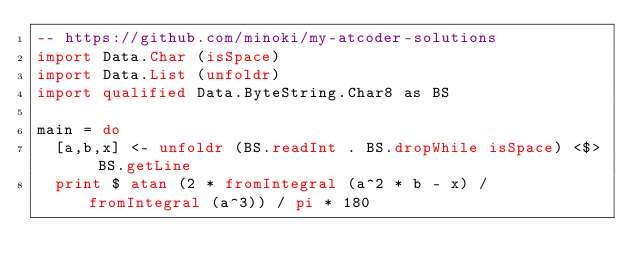Convert code to text. <code><loc_0><loc_0><loc_500><loc_500><_Haskell_>-- https://github.com/minoki/my-atcoder-solutions
import Data.Char (isSpace)
import Data.List (unfoldr)
import qualified Data.ByteString.Char8 as BS

main = do
  [a,b,x] <- unfoldr (BS.readInt . BS.dropWhile isSpace) <$> BS.getLine
  print $ atan (2 * fromIntegral (a^2 * b - x) / fromIntegral (a^3)) / pi * 180
</code> 